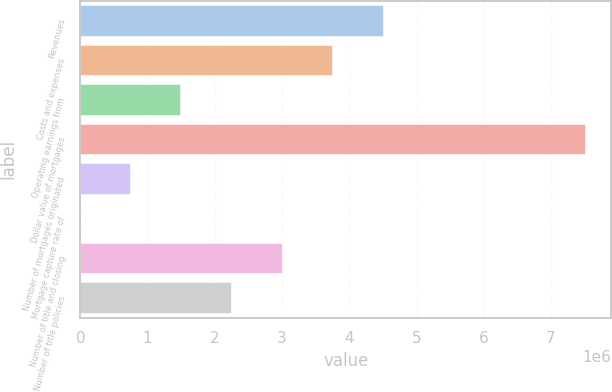<chart> <loc_0><loc_0><loc_500><loc_500><bar_chart><fcel>Revenues<fcel>Costs and expenses<fcel>Operating earnings from<fcel>Dollar value of mortgages<fcel>Number of mortgages originated<fcel>Mortgage capture rate of<fcel>Number of title and closing<fcel>Number of title policies<nl><fcel>4.51023e+06<fcel>3.75854e+06<fcel>1.50346e+06<fcel>7.517e+06<fcel>751764<fcel>71<fcel>3.00684e+06<fcel>2.25515e+06<nl></chart> 